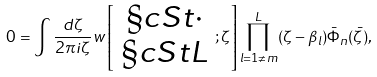Convert formula to latex. <formula><loc_0><loc_0><loc_500><loc_500>0 = \int \frac { d \zeta } { 2 \pi i \zeta } w \left [ \begin{array} { c } \S c S t \cdot \\ \S c S t L \end{array} ; \zeta \right ] \prod ^ { L } _ { l = 1 \neq m } ( \zeta - \beta _ { l } ) \bar { \Phi } _ { n } ( \bar { \zeta } ) ,</formula> 